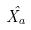<formula> <loc_0><loc_0><loc_500><loc_500>\hat { X _ { a } }</formula> 